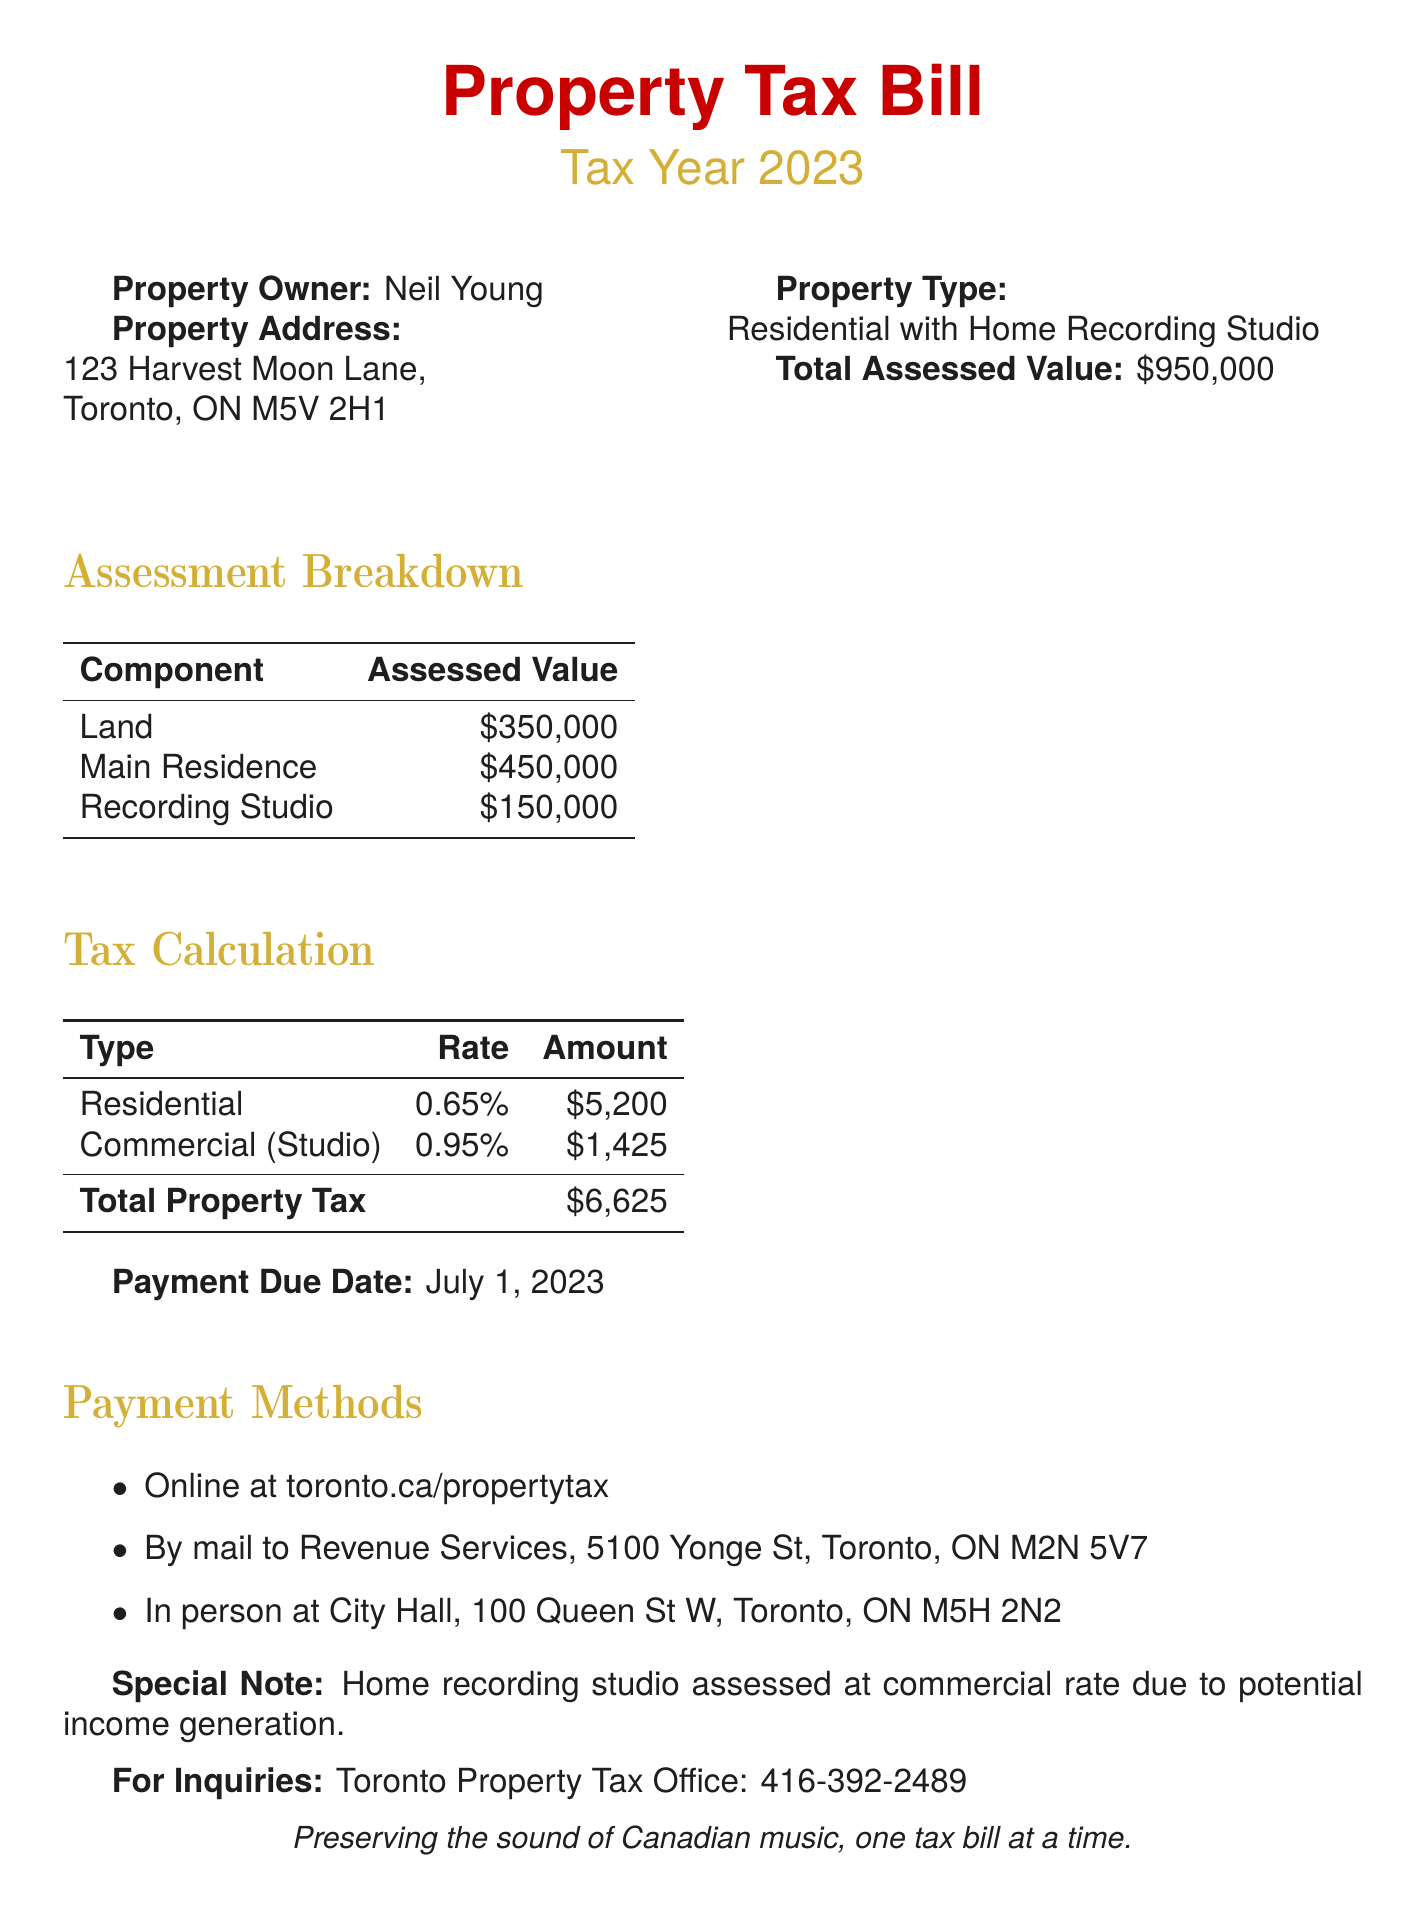what is the total assessed value? The total assessed value is stated at the top of the assessment breakdown in the document.
Answer: $950,000 who is the property owner? The property owner's name is mentioned prominently at the beginning of the document.
Answer: Neil Young what is the payment due date? The payment due date is displayed clearly in the document under the relevant section.
Answer: July 1, 2023 what is the assessed value of the recording studio? The assessed value for the recording studio can be found in the assessment breakdown table.
Answer: $150,000 what is the residential tax rate? The tax rate for the residential property is noted in the tax calculation table of the document.
Answer: 0.65% how much is the total property tax? The total property tax is calculated and shown at the bottom of the tax calculation table.
Answer: $6,625 what is the commercial tax rate for the studio? The document provides the commercial tax rate specifically for the recording studio in the tax calculation section.
Answer: 0.95% why is the home recording studio assessed at a commercial rate? The document explains this in a special note regarding the tax assessment.
Answer: Income generation what are the payment methods mentioned? The document lists various methods for making the payment, indicated in the payment methods section.
Answer: Online, By mail, In person 